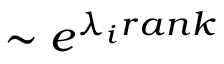Convert formula to latex. <formula><loc_0><loc_0><loc_500><loc_500>\sim e ^ { \lambda _ { i } r a n k }</formula> 